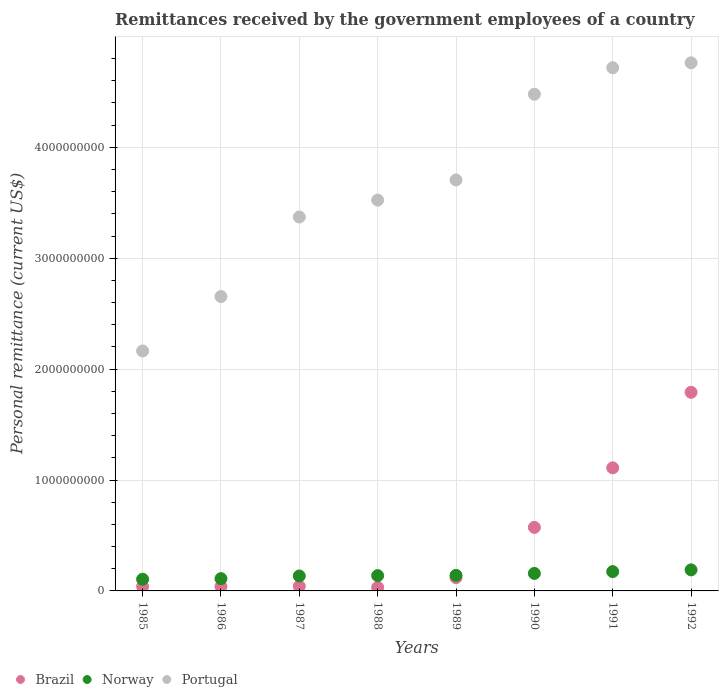How many different coloured dotlines are there?
Your response must be concise. 3. What is the remittances received by the government employees in Norway in 1988?
Offer a terse response. 1.38e+08. Across all years, what is the maximum remittances received by the government employees in Portugal?
Your answer should be very brief. 4.76e+09. Across all years, what is the minimum remittances received by the government employees in Portugal?
Provide a succinct answer. 2.16e+09. In which year was the remittances received by the government employees in Brazil minimum?
Your response must be concise. 1988. What is the total remittances received by the government employees in Norway in the graph?
Make the answer very short. 1.15e+09. What is the difference between the remittances received by the government employees in Brazil in 1987 and that in 1989?
Offer a terse response. -7.80e+07. What is the difference between the remittances received by the government employees in Portugal in 1989 and the remittances received by the government employees in Norway in 1986?
Your answer should be very brief. 3.59e+09. What is the average remittances received by the government employees in Portugal per year?
Your response must be concise. 3.67e+09. In the year 1990, what is the difference between the remittances received by the government employees in Brazil and remittances received by the government employees in Portugal?
Provide a short and direct response. -3.91e+09. In how many years, is the remittances received by the government employees in Norway greater than 3600000000 US$?
Ensure brevity in your answer.  0. What is the ratio of the remittances received by the government employees in Norway in 1985 to that in 1987?
Your answer should be compact. 0.78. Is the remittances received by the government employees in Portugal in 1989 less than that in 1991?
Provide a short and direct response. Yes. What is the difference between the highest and the second highest remittances received by the government employees in Portugal?
Provide a short and direct response. 4.45e+07. What is the difference between the highest and the lowest remittances received by the government employees in Portugal?
Ensure brevity in your answer.  2.60e+09. Is the sum of the remittances received by the government employees in Brazil in 1987 and 1988 greater than the maximum remittances received by the government employees in Portugal across all years?
Your answer should be compact. No. Is it the case that in every year, the sum of the remittances received by the government employees in Portugal and remittances received by the government employees in Norway  is greater than the remittances received by the government employees in Brazil?
Offer a terse response. Yes. Does the remittances received by the government employees in Portugal monotonically increase over the years?
Give a very brief answer. Yes. Is the remittances received by the government employees in Brazil strictly greater than the remittances received by the government employees in Norway over the years?
Offer a very short reply. No. What is the difference between two consecutive major ticks on the Y-axis?
Your response must be concise. 1.00e+09. Are the values on the major ticks of Y-axis written in scientific E-notation?
Ensure brevity in your answer.  No. How many legend labels are there?
Your response must be concise. 3. How are the legend labels stacked?
Your answer should be very brief. Horizontal. What is the title of the graph?
Give a very brief answer. Remittances received by the government employees of a country. Does "Cayman Islands" appear as one of the legend labels in the graph?
Your answer should be very brief. No. What is the label or title of the X-axis?
Your answer should be very brief. Years. What is the label or title of the Y-axis?
Provide a short and direct response. Personal remittance (current US$). What is the Personal remittance (current US$) in Brazil in 1985?
Give a very brief answer. 4.00e+07. What is the Personal remittance (current US$) in Norway in 1985?
Give a very brief answer. 1.05e+08. What is the Personal remittance (current US$) in Portugal in 1985?
Ensure brevity in your answer.  2.16e+09. What is the Personal remittance (current US$) of Brazil in 1986?
Offer a terse response. 4.00e+07. What is the Personal remittance (current US$) of Norway in 1986?
Make the answer very short. 1.11e+08. What is the Personal remittance (current US$) in Portugal in 1986?
Your answer should be very brief. 2.65e+09. What is the Personal remittance (current US$) of Brazil in 1987?
Give a very brief answer. 4.20e+07. What is the Personal remittance (current US$) of Norway in 1987?
Offer a terse response. 1.35e+08. What is the Personal remittance (current US$) in Portugal in 1987?
Your answer should be very brief. 3.37e+09. What is the Personal remittance (current US$) of Brazil in 1988?
Your response must be concise. 3.20e+07. What is the Personal remittance (current US$) of Norway in 1988?
Your answer should be very brief. 1.38e+08. What is the Personal remittance (current US$) of Portugal in 1988?
Ensure brevity in your answer.  3.52e+09. What is the Personal remittance (current US$) in Brazil in 1989?
Your response must be concise. 1.20e+08. What is the Personal remittance (current US$) of Norway in 1989?
Ensure brevity in your answer.  1.40e+08. What is the Personal remittance (current US$) of Portugal in 1989?
Make the answer very short. 3.71e+09. What is the Personal remittance (current US$) in Brazil in 1990?
Your answer should be compact. 5.73e+08. What is the Personal remittance (current US$) of Norway in 1990?
Your answer should be very brief. 1.58e+08. What is the Personal remittance (current US$) in Portugal in 1990?
Your answer should be very brief. 4.48e+09. What is the Personal remittance (current US$) of Brazil in 1991?
Offer a very short reply. 1.11e+09. What is the Personal remittance (current US$) in Norway in 1991?
Make the answer very short. 1.74e+08. What is the Personal remittance (current US$) of Portugal in 1991?
Your answer should be very brief. 4.72e+09. What is the Personal remittance (current US$) of Brazil in 1992?
Keep it short and to the point. 1.79e+09. What is the Personal remittance (current US$) in Norway in 1992?
Keep it short and to the point. 1.90e+08. What is the Personal remittance (current US$) of Portugal in 1992?
Offer a terse response. 4.76e+09. Across all years, what is the maximum Personal remittance (current US$) of Brazil?
Ensure brevity in your answer.  1.79e+09. Across all years, what is the maximum Personal remittance (current US$) of Norway?
Your answer should be compact. 1.90e+08. Across all years, what is the maximum Personal remittance (current US$) of Portugal?
Your answer should be compact. 4.76e+09. Across all years, what is the minimum Personal remittance (current US$) of Brazil?
Your answer should be very brief. 3.20e+07. Across all years, what is the minimum Personal remittance (current US$) of Norway?
Your response must be concise. 1.05e+08. Across all years, what is the minimum Personal remittance (current US$) in Portugal?
Offer a very short reply. 2.16e+09. What is the total Personal remittance (current US$) of Brazil in the graph?
Your response must be concise. 3.75e+09. What is the total Personal remittance (current US$) in Norway in the graph?
Your response must be concise. 1.15e+09. What is the total Personal remittance (current US$) of Portugal in the graph?
Keep it short and to the point. 2.94e+1. What is the difference between the Personal remittance (current US$) in Norway in 1985 and that in 1986?
Make the answer very short. -5.41e+06. What is the difference between the Personal remittance (current US$) in Portugal in 1985 and that in 1986?
Your answer should be very brief. -4.91e+08. What is the difference between the Personal remittance (current US$) of Brazil in 1985 and that in 1987?
Your response must be concise. -2.00e+06. What is the difference between the Personal remittance (current US$) in Norway in 1985 and that in 1987?
Ensure brevity in your answer.  -2.94e+07. What is the difference between the Personal remittance (current US$) in Portugal in 1985 and that in 1987?
Your response must be concise. -1.21e+09. What is the difference between the Personal remittance (current US$) in Brazil in 1985 and that in 1988?
Your answer should be compact. 8.00e+06. What is the difference between the Personal remittance (current US$) in Norway in 1985 and that in 1988?
Keep it short and to the point. -3.25e+07. What is the difference between the Personal remittance (current US$) of Portugal in 1985 and that in 1988?
Offer a terse response. -1.36e+09. What is the difference between the Personal remittance (current US$) in Brazil in 1985 and that in 1989?
Offer a terse response. -8.00e+07. What is the difference between the Personal remittance (current US$) of Norway in 1985 and that in 1989?
Ensure brevity in your answer.  -3.49e+07. What is the difference between the Personal remittance (current US$) of Portugal in 1985 and that in 1989?
Provide a succinct answer. -1.54e+09. What is the difference between the Personal remittance (current US$) of Brazil in 1985 and that in 1990?
Provide a succinct answer. -5.33e+08. What is the difference between the Personal remittance (current US$) of Norway in 1985 and that in 1990?
Offer a very short reply. -5.24e+07. What is the difference between the Personal remittance (current US$) in Portugal in 1985 and that in 1990?
Give a very brief answer. -2.32e+09. What is the difference between the Personal remittance (current US$) of Brazil in 1985 and that in 1991?
Provide a succinct answer. -1.07e+09. What is the difference between the Personal remittance (current US$) in Norway in 1985 and that in 1991?
Provide a short and direct response. -6.88e+07. What is the difference between the Personal remittance (current US$) of Portugal in 1985 and that in 1991?
Give a very brief answer. -2.55e+09. What is the difference between the Personal remittance (current US$) of Brazil in 1985 and that in 1992?
Keep it short and to the point. -1.75e+09. What is the difference between the Personal remittance (current US$) in Norway in 1985 and that in 1992?
Provide a succinct answer. -8.44e+07. What is the difference between the Personal remittance (current US$) of Portugal in 1985 and that in 1992?
Ensure brevity in your answer.  -2.60e+09. What is the difference between the Personal remittance (current US$) in Norway in 1986 and that in 1987?
Provide a succinct answer. -2.40e+07. What is the difference between the Personal remittance (current US$) of Portugal in 1986 and that in 1987?
Your answer should be compact. -7.17e+08. What is the difference between the Personal remittance (current US$) in Norway in 1986 and that in 1988?
Offer a terse response. -2.71e+07. What is the difference between the Personal remittance (current US$) in Portugal in 1986 and that in 1988?
Offer a terse response. -8.70e+08. What is the difference between the Personal remittance (current US$) in Brazil in 1986 and that in 1989?
Offer a terse response. -8.00e+07. What is the difference between the Personal remittance (current US$) in Norway in 1986 and that in 1989?
Provide a succinct answer. -2.95e+07. What is the difference between the Personal remittance (current US$) in Portugal in 1986 and that in 1989?
Your answer should be very brief. -1.05e+09. What is the difference between the Personal remittance (current US$) of Brazil in 1986 and that in 1990?
Offer a very short reply. -5.33e+08. What is the difference between the Personal remittance (current US$) in Norway in 1986 and that in 1990?
Offer a very short reply. -4.70e+07. What is the difference between the Personal remittance (current US$) in Portugal in 1986 and that in 1990?
Keep it short and to the point. -1.82e+09. What is the difference between the Personal remittance (current US$) in Brazil in 1986 and that in 1991?
Make the answer very short. -1.07e+09. What is the difference between the Personal remittance (current US$) of Norway in 1986 and that in 1991?
Offer a very short reply. -6.34e+07. What is the difference between the Personal remittance (current US$) of Portugal in 1986 and that in 1991?
Provide a short and direct response. -2.06e+09. What is the difference between the Personal remittance (current US$) in Brazil in 1986 and that in 1992?
Provide a succinct answer. -1.75e+09. What is the difference between the Personal remittance (current US$) of Norway in 1986 and that in 1992?
Your response must be concise. -7.90e+07. What is the difference between the Personal remittance (current US$) in Portugal in 1986 and that in 1992?
Your response must be concise. -2.11e+09. What is the difference between the Personal remittance (current US$) of Brazil in 1987 and that in 1988?
Give a very brief answer. 1.00e+07. What is the difference between the Personal remittance (current US$) in Norway in 1987 and that in 1988?
Keep it short and to the point. -3.08e+06. What is the difference between the Personal remittance (current US$) of Portugal in 1987 and that in 1988?
Give a very brief answer. -1.52e+08. What is the difference between the Personal remittance (current US$) of Brazil in 1987 and that in 1989?
Offer a terse response. -7.80e+07. What is the difference between the Personal remittance (current US$) in Norway in 1987 and that in 1989?
Make the answer very short. -5.47e+06. What is the difference between the Personal remittance (current US$) of Portugal in 1987 and that in 1989?
Offer a very short reply. -3.34e+08. What is the difference between the Personal remittance (current US$) in Brazil in 1987 and that in 1990?
Your answer should be compact. -5.31e+08. What is the difference between the Personal remittance (current US$) of Norway in 1987 and that in 1990?
Offer a very short reply. -2.30e+07. What is the difference between the Personal remittance (current US$) in Portugal in 1987 and that in 1990?
Provide a succinct answer. -1.11e+09. What is the difference between the Personal remittance (current US$) in Brazil in 1987 and that in 1991?
Give a very brief answer. -1.07e+09. What is the difference between the Personal remittance (current US$) of Norway in 1987 and that in 1991?
Your response must be concise. -3.94e+07. What is the difference between the Personal remittance (current US$) of Portugal in 1987 and that in 1991?
Your response must be concise. -1.35e+09. What is the difference between the Personal remittance (current US$) of Brazil in 1987 and that in 1992?
Your response must be concise. -1.75e+09. What is the difference between the Personal remittance (current US$) in Norway in 1987 and that in 1992?
Give a very brief answer. -5.50e+07. What is the difference between the Personal remittance (current US$) of Portugal in 1987 and that in 1992?
Provide a succinct answer. -1.39e+09. What is the difference between the Personal remittance (current US$) in Brazil in 1988 and that in 1989?
Make the answer very short. -8.80e+07. What is the difference between the Personal remittance (current US$) in Norway in 1988 and that in 1989?
Your answer should be very brief. -2.40e+06. What is the difference between the Personal remittance (current US$) of Portugal in 1988 and that in 1989?
Your answer should be very brief. -1.82e+08. What is the difference between the Personal remittance (current US$) in Brazil in 1988 and that in 1990?
Offer a terse response. -5.41e+08. What is the difference between the Personal remittance (current US$) in Norway in 1988 and that in 1990?
Provide a short and direct response. -1.99e+07. What is the difference between the Personal remittance (current US$) of Portugal in 1988 and that in 1990?
Give a very brief answer. -9.55e+08. What is the difference between the Personal remittance (current US$) of Brazil in 1988 and that in 1991?
Your response must be concise. -1.08e+09. What is the difference between the Personal remittance (current US$) in Norway in 1988 and that in 1991?
Ensure brevity in your answer.  -3.63e+07. What is the difference between the Personal remittance (current US$) of Portugal in 1988 and that in 1991?
Provide a succinct answer. -1.19e+09. What is the difference between the Personal remittance (current US$) in Brazil in 1988 and that in 1992?
Give a very brief answer. -1.76e+09. What is the difference between the Personal remittance (current US$) in Norway in 1988 and that in 1992?
Offer a terse response. -5.19e+07. What is the difference between the Personal remittance (current US$) of Portugal in 1988 and that in 1992?
Ensure brevity in your answer.  -1.24e+09. What is the difference between the Personal remittance (current US$) in Brazil in 1989 and that in 1990?
Give a very brief answer. -4.53e+08. What is the difference between the Personal remittance (current US$) in Norway in 1989 and that in 1990?
Your answer should be compact. -1.75e+07. What is the difference between the Personal remittance (current US$) in Portugal in 1989 and that in 1990?
Give a very brief answer. -7.73e+08. What is the difference between the Personal remittance (current US$) of Brazil in 1989 and that in 1991?
Offer a very short reply. -9.90e+08. What is the difference between the Personal remittance (current US$) of Norway in 1989 and that in 1991?
Provide a succinct answer. -3.39e+07. What is the difference between the Personal remittance (current US$) in Portugal in 1989 and that in 1991?
Ensure brevity in your answer.  -1.01e+09. What is the difference between the Personal remittance (current US$) in Brazil in 1989 and that in 1992?
Offer a very short reply. -1.67e+09. What is the difference between the Personal remittance (current US$) in Norway in 1989 and that in 1992?
Your answer should be very brief. -4.95e+07. What is the difference between the Personal remittance (current US$) in Portugal in 1989 and that in 1992?
Provide a succinct answer. -1.06e+09. What is the difference between the Personal remittance (current US$) of Brazil in 1990 and that in 1991?
Your response must be concise. -5.37e+08. What is the difference between the Personal remittance (current US$) in Norway in 1990 and that in 1991?
Provide a short and direct response. -1.64e+07. What is the difference between the Personal remittance (current US$) of Portugal in 1990 and that in 1991?
Make the answer very short. -2.39e+08. What is the difference between the Personal remittance (current US$) of Brazil in 1990 and that in 1992?
Your answer should be very brief. -1.22e+09. What is the difference between the Personal remittance (current US$) of Norway in 1990 and that in 1992?
Offer a very short reply. -3.21e+07. What is the difference between the Personal remittance (current US$) of Portugal in 1990 and that in 1992?
Your response must be concise. -2.83e+08. What is the difference between the Personal remittance (current US$) of Brazil in 1991 and that in 1992?
Provide a succinct answer. -6.81e+08. What is the difference between the Personal remittance (current US$) of Norway in 1991 and that in 1992?
Your response must be concise. -1.56e+07. What is the difference between the Personal remittance (current US$) of Portugal in 1991 and that in 1992?
Give a very brief answer. -4.45e+07. What is the difference between the Personal remittance (current US$) in Brazil in 1985 and the Personal remittance (current US$) in Norway in 1986?
Offer a terse response. -7.08e+07. What is the difference between the Personal remittance (current US$) in Brazil in 1985 and the Personal remittance (current US$) in Portugal in 1986?
Provide a succinct answer. -2.61e+09. What is the difference between the Personal remittance (current US$) in Norway in 1985 and the Personal remittance (current US$) in Portugal in 1986?
Provide a succinct answer. -2.55e+09. What is the difference between the Personal remittance (current US$) in Brazil in 1985 and the Personal remittance (current US$) in Norway in 1987?
Your answer should be compact. -9.49e+07. What is the difference between the Personal remittance (current US$) in Brazil in 1985 and the Personal remittance (current US$) in Portugal in 1987?
Ensure brevity in your answer.  -3.33e+09. What is the difference between the Personal remittance (current US$) in Norway in 1985 and the Personal remittance (current US$) in Portugal in 1987?
Provide a succinct answer. -3.27e+09. What is the difference between the Personal remittance (current US$) of Brazil in 1985 and the Personal remittance (current US$) of Norway in 1988?
Offer a terse response. -9.79e+07. What is the difference between the Personal remittance (current US$) of Brazil in 1985 and the Personal remittance (current US$) of Portugal in 1988?
Offer a very short reply. -3.48e+09. What is the difference between the Personal remittance (current US$) of Norway in 1985 and the Personal remittance (current US$) of Portugal in 1988?
Your response must be concise. -3.42e+09. What is the difference between the Personal remittance (current US$) in Brazil in 1985 and the Personal remittance (current US$) in Norway in 1989?
Your response must be concise. -1.00e+08. What is the difference between the Personal remittance (current US$) of Brazil in 1985 and the Personal remittance (current US$) of Portugal in 1989?
Offer a terse response. -3.67e+09. What is the difference between the Personal remittance (current US$) of Norway in 1985 and the Personal remittance (current US$) of Portugal in 1989?
Your answer should be compact. -3.60e+09. What is the difference between the Personal remittance (current US$) of Brazil in 1985 and the Personal remittance (current US$) of Norway in 1990?
Provide a succinct answer. -1.18e+08. What is the difference between the Personal remittance (current US$) in Brazil in 1985 and the Personal remittance (current US$) in Portugal in 1990?
Offer a terse response. -4.44e+09. What is the difference between the Personal remittance (current US$) of Norway in 1985 and the Personal remittance (current US$) of Portugal in 1990?
Your response must be concise. -4.37e+09. What is the difference between the Personal remittance (current US$) of Brazil in 1985 and the Personal remittance (current US$) of Norway in 1991?
Provide a short and direct response. -1.34e+08. What is the difference between the Personal remittance (current US$) of Brazil in 1985 and the Personal remittance (current US$) of Portugal in 1991?
Offer a very short reply. -4.68e+09. What is the difference between the Personal remittance (current US$) in Norway in 1985 and the Personal remittance (current US$) in Portugal in 1991?
Your answer should be very brief. -4.61e+09. What is the difference between the Personal remittance (current US$) in Brazil in 1985 and the Personal remittance (current US$) in Norway in 1992?
Provide a short and direct response. -1.50e+08. What is the difference between the Personal remittance (current US$) in Brazil in 1985 and the Personal remittance (current US$) in Portugal in 1992?
Your response must be concise. -4.72e+09. What is the difference between the Personal remittance (current US$) of Norway in 1985 and the Personal remittance (current US$) of Portugal in 1992?
Keep it short and to the point. -4.66e+09. What is the difference between the Personal remittance (current US$) of Brazil in 1986 and the Personal remittance (current US$) of Norway in 1987?
Your response must be concise. -9.49e+07. What is the difference between the Personal remittance (current US$) of Brazil in 1986 and the Personal remittance (current US$) of Portugal in 1987?
Your answer should be compact. -3.33e+09. What is the difference between the Personal remittance (current US$) in Norway in 1986 and the Personal remittance (current US$) in Portugal in 1987?
Your answer should be compact. -3.26e+09. What is the difference between the Personal remittance (current US$) in Brazil in 1986 and the Personal remittance (current US$) in Norway in 1988?
Give a very brief answer. -9.79e+07. What is the difference between the Personal remittance (current US$) of Brazil in 1986 and the Personal remittance (current US$) of Portugal in 1988?
Make the answer very short. -3.48e+09. What is the difference between the Personal remittance (current US$) of Norway in 1986 and the Personal remittance (current US$) of Portugal in 1988?
Your answer should be compact. -3.41e+09. What is the difference between the Personal remittance (current US$) in Brazil in 1986 and the Personal remittance (current US$) in Norway in 1989?
Offer a very short reply. -1.00e+08. What is the difference between the Personal remittance (current US$) in Brazil in 1986 and the Personal remittance (current US$) in Portugal in 1989?
Ensure brevity in your answer.  -3.67e+09. What is the difference between the Personal remittance (current US$) of Norway in 1986 and the Personal remittance (current US$) of Portugal in 1989?
Your response must be concise. -3.59e+09. What is the difference between the Personal remittance (current US$) in Brazil in 1986 and the Personal remittance (current US$) in Norway in 1990?
Provide a short and direct response. -1.18e+08. What is the difference between the Personal remittance (current US$) of Brazil in 1986 and the Personal remittance (current US$) of Portugal in 1990?
Ensure brevity in your answer.  -4.44e+09. What is the difference between the Personal remittance (current US$) in Norway in 1986 and the Personal remittance (current US$) in Portugal in 1990?
Provide a short and direct response. -4.37e+09. What is the difference between the Personal remittance (current US$) in Brazil in 1986 and the Personal remittance (current US$) in Norway in 1991?
Give a very brief answer. -1.34e+08. What is the difference between the Personal remittance (current US$) in Brazil in 1986 and the Personal remittance (current US$) in Portugal in 1991?
Provide a succinct answer. -4.68e+09. What is the difference between the Personal remittance (current US$) in Norway in 1986 and the Personal remittance (current US$) in Portugal in 1991?
Your answer should be very brief. -4.61e+09. What is the difference between the Personal remittance (current US$) in Brazil in 1986 and the Personal remittance (current US$) in Norway in 1992?
Your answer should be very brief. -1.50e+08. What is the difference between the Personal remittance (current US$) in Brazil in 1986 and the Personal remittance (current US$) in Portugal in 1992?
Provide a succinct answer. -4.72e+09. What is the difference between the Personal remittance (current US$) of Norway in 1986 and the Personal remittance (current US$) of Portugal in 1992?
Offer a terse response. -4.65e+09. What is the difference between the Personal remittance (current US$) of Brazil in 1987 and the Personal remittance (current US$) of Norway in 1988?
Provide a short and direct response. -9.59e+07. What is the difference between the Personal remittance (current US$) of Brazil in 1987 and the Personal remittance (current US$) of Portugal in 1988?
Offer a very short reply. -3.48e+09. What is the difference between the Personal remittance (current US$) in Norway in 1987 and the Personal remittance (current US$) in Portugal in 1988?
Provide a short and direct response. -3.39e+09. What is the difference between the Personal remittance (current US$) in Brazil in 1987 and the Personal remittance (current US$) in Norway in 1989?
Give a very brief answer. -9.83e+07. What is the difference between the Personal remittance (current US$) of Brazil in 1987 and the Personal remittance (current US$) of Portugal in 1989?
Offer a terse response. -3.66e+09. What is the difference between the Personal remittance (current US$) in Norway in 1987 and the Personal remittance (current US$) in Portugal in 1989?
Give a very brief answer. -3.57e+09. What is the difference between the Personal remittance (current US$) of Brazil in 1987 and the Personal remittance (current US$) of Norway in 1990?
Your response must be concise. -1.16e+08. What is the difference between the Personal remittance (current US$) in Brazil in 1987 and the Personal remittance (current US$) in Portugal in 1990?
Offer a very short reply. -4.44e+09. What is the difference between the Personal remittance (current US$) of Norway in 1987 and the Personal remittance (current US$) of Portugal in 1990?
Ensure brevity in your answer.  -4.34e+09. What is the difference between the Personal remittance (current US$) in Brazil in 1987 and the Personal remittance (current US$) in Norway in 1991?
Offer a terse response. -1.32e+08. What is the difference between the Personal remittance (current US$) in Brazil in 1987 and the Personal remittance (current US$) in Portugal in 1991?
Your answer should be compact. -4.68e+09. What is the difference between the Personal remittance (current US$) in Norway in 1987 and the Personal remittance (current US$) in Portugal in 1991?
Ensure brevity in your answer.  -4.58e+09. What is the difference between the Personal remittance (current US$) in Brazil in 1987 and the Personal remittance (current US$) in Norway in 1992?
Make the answer very short. -1.48e+08. What is the difference between the Personal remittance (current US$) in Brazil in 1987 and the Personal remittance (current US$) in Portugal in 1992?
Keep it short and to the point. -4.72e+09. What is the difference between the Personal remittance (current US$) in Norway in 1987 and the Personal remittance (current US$) in Portugal in 1992?
Provide a succinct answer. -4.63e+09. What is the difference between the Personal remittance (current US$) in Brazil in 1988 and the Personal remittance (current US$) in Norway in 1989?
Offer a terse response. -1.08e+08. What is the difference between the Personal remittance (current US$) of Brazil in 1988 and the Personal remittance (current US$) of Portugal in 1989?
Offer a very short reply. -3.67e+09. What is the difference between the Personal remittance (current US$) in Norway in 1988 and the Personal remittance (current US$) in Portugal in 1989?
Make the answer very short. -3.57e+09. What is the difference between the Personal remittance (current US$) in Brazil in 1988 and the Personal remittance (current US$) in Norway in 1990?
Your answer should be compact. -1.26e+08. What is the difference between the Personal remittance (current US$) of Brazil in 1988 and the Personal remittance (current US$) of Portugal in 1990?
Provide a succinct answer. -4.45e+09. What is the difference between the Personal remittance (current US$) of Norway in 1988 and the Personal remittance (current US$) of Portugal in 1990?
Give a very brief answer. -4.34e+09. What is the difference between the Personal remittance (current US$) in Brazil in 1988 and the Personal remittance (current US$) in Norway in 1991?
Provide a short and direct response. -1.42e+08. What is the difference between the Personal remittance (current US$) in Brazil in 1988 and the Personal remittance (current US$) in Portugal in 1991?
Provide a succinct answer. -4.69e+09. What is the difference between the Personal remittance (current US$) in Norway in 1988 and the Personal remittance (current US$) in Portugal in 1991?
Keep it short and to the point. -4.58e+09. What is the difference between the Personal remittance (current US$) of Brazil in 1988 and the Personal remittance (current US$) of Norway in 1992?
Make the answer very short. -1.58e+08. What is the difference between the Personal remittance (current US$) of Brazil in 1988 and the Personal remittance (current US$) of Portugal in 1992?
Offer a terse response. -4.73e+09. What is the difference between the Personal remittance (current US$) of Norway in 1988 and the Personal remittance (current US$) of Portugal in 1992?
Your answer should be compact. -4.62e+09. What is the difference between the Personal remittance (current US$) of Brazil in 1989 and the Personal remittance (current US$) of Norway in 1990?
Your answer should be very brief. -3.78e+07. What is the difference between the Personal remittance (current US$) in Brazil in 1989 and the Personal remittance (current US$) in Portugal in 1990?
Give a very brief answer. -4.36e+09. What is the difference between the Personal remittance (current US$) in Norway in 1989 and the Personal remittance (current US$) in Portugal in 1990?
Your answer should be compact. -4.34e+09. What is the difference between the Personal remittance (current US$) of Brazil in 1989 and the Personal remittance (current US$) of Norway in 1991?
Make the answer very short. -5.42e+07. What is the difference between the Personal remittance (current US$) in Brazil in 1989 and the Personal remittance (current US$) in Portugal in 1991?
Provide a short and direct response. -4.60e+09. What is the difference between the Personal remittance (current US$) of Norway in 1989 and the Personal remittance (current US$) of Portugal in 1991?
Give a very brief answer. -4.58e+09. What is the difference between the Personal remittance (current US$) in Brazil in 1989 and the Personal remittance (current US$) in Norway in 1992?
Ensure brevity in your answer.  -6.99e+07. What is the difference between the Personal remittance (current US$) of Brazil in 1989 and the Personal remittance (current US$) of Portugal in 1992?
Ensure brevity in your answer.  -4.64e+09. What is the difference between the Personal remittance (current US$) in Norway in 1989 and the Personal remittance (current US$) in Portugal in 1992?
Provide a succinct answer. -4.62e+09. What is the difference between the Personal remittance (current US$) in Brazil in 1990 and the Personal remittance (current US$) in Norway in 1991?
Offer a terse response. 3.99e+08. What is the difference between the Personal remittance (current US$) in Brazil in 1990 and the Personal remittance (current US$) in Portugal in 1991?
Offer a very short reply. -4.14e+09. What is the difference between the Personal remittance (current US$) in Norway in 1990 and the Personal remittance (current US$) in Portugal in 1991?
Offer a very short reply. -4.56e+09. What is the difference between the Personal remittance (current US$) in Brazil in 1990 and the Personal remittance (current US$) in Norway in 1992?
Ensure brevity in your answer.  3.83e+08. What is the difference between the Personal remittance (current US$) of Brazil in 1990 and the Personal remittance (current US$) of Portugal in 1992?
Offer a terse response. -4.19e+09. What is the difference between the Personal remittance (current US$) of Norway in 1990 and the Personal remittance (current US$) of Portugal in 1992?
Your response must be concise. -4.60e+09. What is the difference between the Personal remittance (current US$) in Brazil in 1991 and the Personal remittance (current US$) in Norway in 1992?
Offer a very short reply. 9.20e+08. What is the difference between the Personal remittance (current US$) of Brazil in 1991 and the Personal remittance (current US$) of Portugal in 1992?
Your response must be concise. -3.65e+09. What is the difference between the Personal remittance (current US$) in Norway in 1991 and the Personal remittance (current US$) in Portugal in 1992?
Provide a short and direct response. -4.59e+09. What is the average Personal remittance (current US$) of Brazil per year?
Your answer should be very brief. 4.68e+08. What is the average Personal remittance (current US$) in Norway per year?
Your answer should be very brief. 1.44e+08. What is the average Personal remittance (current US$) in Portugal per year?
Your answer should be compact. 3.67e+09. In the year 1985, what is the difference between the Personal remittance (current US$) of Brazil and Personal remittance (current US$) of Norway?
Your response must be concise. -6.54e+07. In the year 1985, what is the difference between the Personal remittance (current US$) of Brazil and Personal remittance (current US$) of Portugal?
Ensure brevity in your answer.  -2.12e+09. In the year 1985, what is the difference between the Personal remittance (current US$) in Norway and Personal remittance (current US$) in Portugal?
Keep it short and to the point. -2.06e+09. In the year 1986, what is the difference between the Personal remittance (current US$) in Brazil and Personal remittance (current US$) in Norway?
Your response must be concise. -7.08e+07. In the year 1986, what is the difference between the Personal remittance (current US$) of Brazil and Personal remittance (current US$) of Portugal?
Provide a short and direct response. -2.61e+09. In the year 1986, what is the difference between the Personal remittance (current US$) in Norway and Personal remittance (current US$) in Portugal?
Offer a very short reply. -2.54e+09. In the year 1987, what is the difference between the Personal remittance (current US$) of Brazil and Personal remittance (current US$) of Norway?
Ensure brevity in your answer.  -9.29e+07. In the year 1987, what is the difference between the Personal remittance (current US$) of Brazil and Personal remittance (current US$) of Portugal?
Offer a terse response. -3.33e+09. In the year 1987, what is the difference between the Personal remittance (current US$) in Norway and Personal remittance (current US$) in Portugal?
Your response must be concise. -3.24e+09. In the year 1988, what is the difference between the Personal remittance (current US$) in Brazil and Personal remittance (current US$) in Norway?
Offer a terse response. -1.06e+08. In the year 1988, what is the difference between the Personal remittance (current US$) of Brazil and Personal remittance (current US$) of Portugal?
Your response must be concise. -3.49e+09. In the year 1988, what is the difference between the Personal remittance (current US$) in Norway and Personal remittance (current US$) in Portugal?
Give a very brief answer. -3.39e+09. In the year 1989, what is the difference between the Personal remittance (current US$) of Brazil and Personal remittance (current US$) of Norway?
Offer a terse response. -2.03e+07. In the year 1989, what is the difference between the Personal remittance (current US$) of Brazil and Personal remittance (current US$) of Portugal?
Provide a succinct answer. -3.59e+09. In the year 1989, what is the difference between the Personal remittance (current US$) of Norway and Personal remittance (current US$) of Portugal?
Ensure brevity in your answer.  -3.57e+09. In the year 1990, what is the difference between the Personal remittance (current US$) of Brazil and Personal remittance (current US$) of Norway?
Your answer should be compact. 4.15e+08. In the year 1990, what is the difference between the Personal remittance (current US$) of Brazil and Personal remittance (current US$) of Portugal?
Make the answer very short. -3.91e+09. In the year 1990, what is the difference between the Personal remittance (current US$) of Norway and Personal remittance (current US$) of Portugal?
Offer a terse response. -4.32e+09. In the year 1991, what is the difference between the Personal remittance (current US$) in Brazil and Personal remittance (current US$) in Norway?
Offer a very short reply. 9.36e+08. In the year 1991, what is the difference between the Personal remittance (current US$) in Brazil and Personal remittance (current US$) in Portugal?
Provide a succinct answer. -3.61e+09. In the year 1991, what is the difference between the Personal remittance (current US$) of Norway and Personal remittance (current US$) of Portugal?
Give a very brief answer. -4.54e+09. In the year 1992, what is the difference between the Personal remittance (current US$) in Brazil and Personal remittance (current US$) in Norway?
Your answer should be compact. 1.60e+09. In the year 1992, what is the difference between the Personal remittance (current US$) of Brazil and Personal remittance (current US$) of Portugal?
Give a very brief answer. -2.97e+09. In the year 1992, what is the difference between the Personal remittance (current US$) of Norway and Personal remittance (current US$) of Portugal?
Keep it short and to the point. -4.57e+09. What is the ratio of the Personal remittance (current US$) of Brazil in 1985 to that in 1986?
Your answer should be very brief. 1. What is the ratio of the Personal remittance (current US$) in Norway in 1985 to that in 1986?
Give a very brief answer. 0.95. What is the ratio of the Personal remittance (current US$) of Portugal in 1985 to that in 1986?
Your response must be concise. 0.82. What is the ratio of the Personal remittance (current US$) of Norway in 1985 to that in 1987?
Keep it short and to the point. 0.78. What is the ratio of the Personal remittance (current US$) of Portugal in 1985 to that in 1987?
Keep it short and to the point. 0.64. What is the ratio of the Personal remittance (current US$) in Brazil in 1985 to that in 1988?
Keep it short and to the point. 1.25. What is the ratio of the Personal remittance (current US$) in Norway in 1985 to that in 1988?
Make the answer very short. 0.76. What is the ratio of the Personal remittance (current US$) of Portugal in 1985 to that in 1988?
Give a very brief answer. 0.61. What is the ratio of the Personal remittance (current US$) of Norway in 1985 to that in 1989?
Offer a very short reply. 0.75. What is the ratio of the Personal remittance (current US$) in Portugal in 1985 to that in 1989?
Keep it short and to the point. 0.58. What is the ratio of the Personal remittance (current US$) of Brazil in 1985 to that in 1990?
Make the answer very short. 0.07. What is the ratio of the Personal remittance (current US$) in Norway in 1985 to that in 1990?
Offer a very short reply. 0.67. What is the ratio of the Personal remittance (current US$) in Portugal in 1985 to that in 1990?
Give a very brief answer. 0.48. What is the ratio of the Personal remittance (current US$) of Brazil in 1985 to that in 1991?
Offer a terse response. 0.04. What is the ratio of the Personal remittance (current US$) in Norway in 1985 to that in 1991?
Keep it short and to the point. 0.61. What is the ratio of the Personal remittance (current US$) of Portugal in 1985 to that in 1991?
Your answer should be very brief. 0.46. What is the ratio of the Personal remittance (current US$) in Brazil in 1985 to that in 1992?
Your answer should be very brief. 0.02. What is the ratio of the Personal remittance (current US$) in Norway in 1985 to that in 1992?
Ensure brevity in your answer.  0.56. What is the ratio of the Personal remittance (current US$) in Portugal in 1985 to that in 1992?
Offer a very short reply. 0.45. What is the ratio of the Personal remittance (current US$) of Brazil in 1986 to that in 1987?
Ensure brevity in your answer.  0.95. What is the ratio of the Personal remittance (current US$) in Norway in 1986 to that in 1987?
Keep it short and to the point. 0.82. What is the ratio of the Personal remittance (current US$) of Portugal in 1986 to that in 1987?
Your response must be concise. 0.79. What is the ratio of the Personal remittance (current US$) in Norway in 1986 to that in 1988?
Offer a very short reply. 0.8. What is the ratio of the Personal remittance (current US$) of Portugal in 1986 to that in 1988?
Offer a very short reply. 0.75. What is the ratio of the Personal remittance (current US$) of Brazil in 1986 to that in 1989?
Your answer should be very brief. 0.33. What is the ratio of the Personal remittance (current US$) in Norway in 1986 to that in 1989?
Your response must be concise. 0.79. What is the ratio of the Personal remittance (current US$) of Portugal in 1986 to that in 1989?
Make the answer very short. 0.72. What is the ratio of the Personal remittance (current US$) in Brazil in 1986 to that in 1990?
Your response must be concise. 0.07. What is the ratio of the Personal remittance (current US$) of Norway in 1986 to that in 1990?
Provide a succinct answer. 0.7. What is the ratio of the Personal remittance (current US$) in Portugal in 1986 to that in 1990?
Make the answer very short. 0.59. What is the ratio of the Personal remittance (current US$) of Brazil in 1986 to that in 1991?
Ensure brevity in your answer.  0.04. What is the ratio of the Personal remittance (current US$) of Norway in 1986 to that in 1991?
Your answer should be compact. 0.64. What is the ratio of the Personal remittance (current US$) in Portugal in 1986 to that in 1991?
Your answer should be compact. 0.56. What is the ratio of the Personal remittance (current US$) of Brazil in 1986 to that in 1992?
Ensure brevity in your answer.  0.02. What is the ratio of the Personal remittance (current US$) in Norway in 1986 to that in 1992?
Ensure brevity in your answer.  0.58. What is the ratio of the Personal remittance (current US$) of Portugal in 1986 to that in 1992?
Your answer should be very brief. 0.56. What is the ratio of the Personal remittance (current US$) in Brazil in 1987 to that in 1988?
Offer a terse response. 1.31. What is the ratio of the Personal remittance (current US$) of Norway in 1987 to that in 1988?
Provide a short and direct response. 0.98. What is the ratio of the Personal remittance (current US$) of Portugal in 1987 to that in 1988?
Provide a succinct answer. 0.96. What is the ratio of the Personal remittance (current US$) in Brazil in 1987 to that in 1989?
Your answer should be very brief. 0.35. What is the ratio of the Personal remittance (current US$) of Portugal in 1987 to that in 1989?
Provide a succinct answer. 0.91. What is the ratio of the Personal remittance (current US$) of Brazil in 1987 to that in 1990?
Keep it short and to the point. 0.07. What is the ratio of the Personal remittance (current US$) of Norway in 1987 to that in 1990?
Your answer should be very brief. 0.85. What is the ratio of the Personal remittance (current US$) of Portugal in 1987 to that in 1990?
Your answer should be very brief. 0.75. What is the ratio of the Personal remittance (current US$) of Brazil in 1987 to that in 1991?
Ensure brevity in your answer.  0.04. What is the ratio of the Personal remittance (current US$) in Norway in 1987 to that in 1991?
Give a very brief answer. 0.77. What is the ratio of the Personal remittance (current US$) of Portugal in 1987 to that in 1991?
Keep it short and to the point. 0.71. What is the ratio of the Personal remittance (current US$) in Brazil in 1987 to that in 1992?
Keep it short and to the point. 0.02. What is the ratio of the Personal remittance (current US$) in Norway in 1987 to that in 1992?
Provide a short and direct response. 0.71. What is the ratio of the Personal remittance (current US$) in Portugal in 1987 to that in 1992?
Give a very brief answer. 0.71. What is the ratio of the Personal remittance (current US$) in Brazil in 1988 to that in 1989?
Provide a succinct answer. 0.27. What is the ratio of the Personal remittance (current US$) in Norway in 1988 to that in 1989?
Your response must be concise. 0.98. What is the ratio of the Personal remittance (current US$) of Portugal in 1988 to that in 1989?
Offer a very short reply. 0.95. What is the ratio of the Personal remittance (current US$) of Brazil in 1988 to that in 1990?
Give a very brief answer. 0.06. What is the ratio of the Personal remittance (current US$) in Norway in 1988 to that in 1990?
Provide a succinct answer. 0.87. What is the ratio of the Personal remittance (current US$) in Portugal in 1988 to that in 1990?
Your answer should be very brief. 0.79. What is the ratio of the Personal remittance (current US$) of Brazil in 1988 to that in 1991?
Give a very brief answer. 0.03. What is the ratio of the Personal remittance (current US$) of Norway in 1988 to that in 1991?
Offer a terse response. 0.79. What is the ratio of the Personal remittance (current US$) of Portugal in 1988 to that in 1991?
Offer a terse response. 0.75. What is the ratio of the Personal remittance (current US$) of Brazil in 1988 to that in 1992?
Offer a very short reply. 0.02. What is the ratio of the Personal remittance (current US$) in Norway in 1988 to that in 1992?
Offer a terse response. 0.73. What is the ratio of the Personal remittance (current US$) of Portugal in 1988 to that in 1992?
Give a very brief answer. 0.74. What is the ratio of the Personal remittance (current US$) of Brazil in 1989 to that in 1990?
Give a very brief answer. 0.21. What is the ratio of the Personal remittance (current US$) in Norway in 1989 to that in 1990?
Keep it short and to the point. 0.89. What is the ratio of the Personal remittance (current US$) in Portugal in 1989 to that in 1990?
Provide a succinct answer. 0.83. What is the ratio of the Personal remittance (current US$) of Brazil in 1989 to that in 1991?
Make the answer very short. 0.11. What is the ratio of the Personal remittance (current US$) in Norway in 1989 to that in 1991?
Keep it short and to the point. 0.81. What is the ratio of the Personal remittance (current US$) in Portugal in 1989 to that in 1991?
Provide a short and direct response. 0.79. What is the ratio of the Personal remittance (current US$) of Brazil in 1989 to that in 1992?
Provide a short and direct response. 0.07. What is the ratio of the Personal remittance (current US$) in Norway in 1989 to that in 1992?
Provide a short and direct response. 0.74. What is the ratio of the Personal remittance (current US$) in Portugal in 1989 to that in 1992?
Your answer should be compact. 0.78. What is the ratio of the Personal remittance (current US$) of Brazil in 1990 to that in 1991?
Make the answer very short. 0.52. What is the ratio of the Personal remittance (current US$) in Norway in 1990 to that in 1991?
Make the answer very short. 0.91. What is the ratio of the Personal remittance (current US$) of Portugal in 1990 to that in 1991?
Ensure brevity in your answer.  0.95. What is the ratio of the Personal remittance (current US$) in Brazil in 1990 to that in 1992?
Offer a terse response. 0.32. What is the ratio of the Personal remittance (current US$) in Norway in 1990 to that in 1992?
Offer a terse response. 0.83. What is the ratio of the Personal remittance (current US$) in Portugal in 1990 to that in 1992?
Keep it short and to the point. 0.94. What is the ratio of the Personal remittance (current US$) in Brazil in 1991 to that in 1992?
Offer a very short reply. 0.62. What is the ratio of the Personal remittance (current US$) of Norway in 1991 to that in 1992?
Your response must be concise. 0.92. What is the ratio of the Personal remittance (current US$) of Portugal in 1991 to that in 1992?
Provide a short and direct response. 0.99. What is the difference between the highest and the second highest Personal remittance (current US$) in Brazil?
Your answer should be compact. 6.81e+08. What is the difference between the highest and the second highest Personal remittance (current US$) of Norway?
Ensure brevity in your answer.  1.56e+07. What is the difference between the highest and the second highest Personal remittance (current US$) in Portugal?
Offer a very short reply. 4.45e+07. What is the difference between the highest and the lowest Personal remittance (current US$) of Brazil?
Provide a succinct answer. 1.76e+09. What is the difference between the highest and the lowest Personal remittance (current US$) of Norway?
Ensure brevity in your answer.  8.44e+07. What is the difference between the highest and the lowest Personal remittance (current US$) of Portugal?
Ensure brevity in your answer.  2.60e+09. 